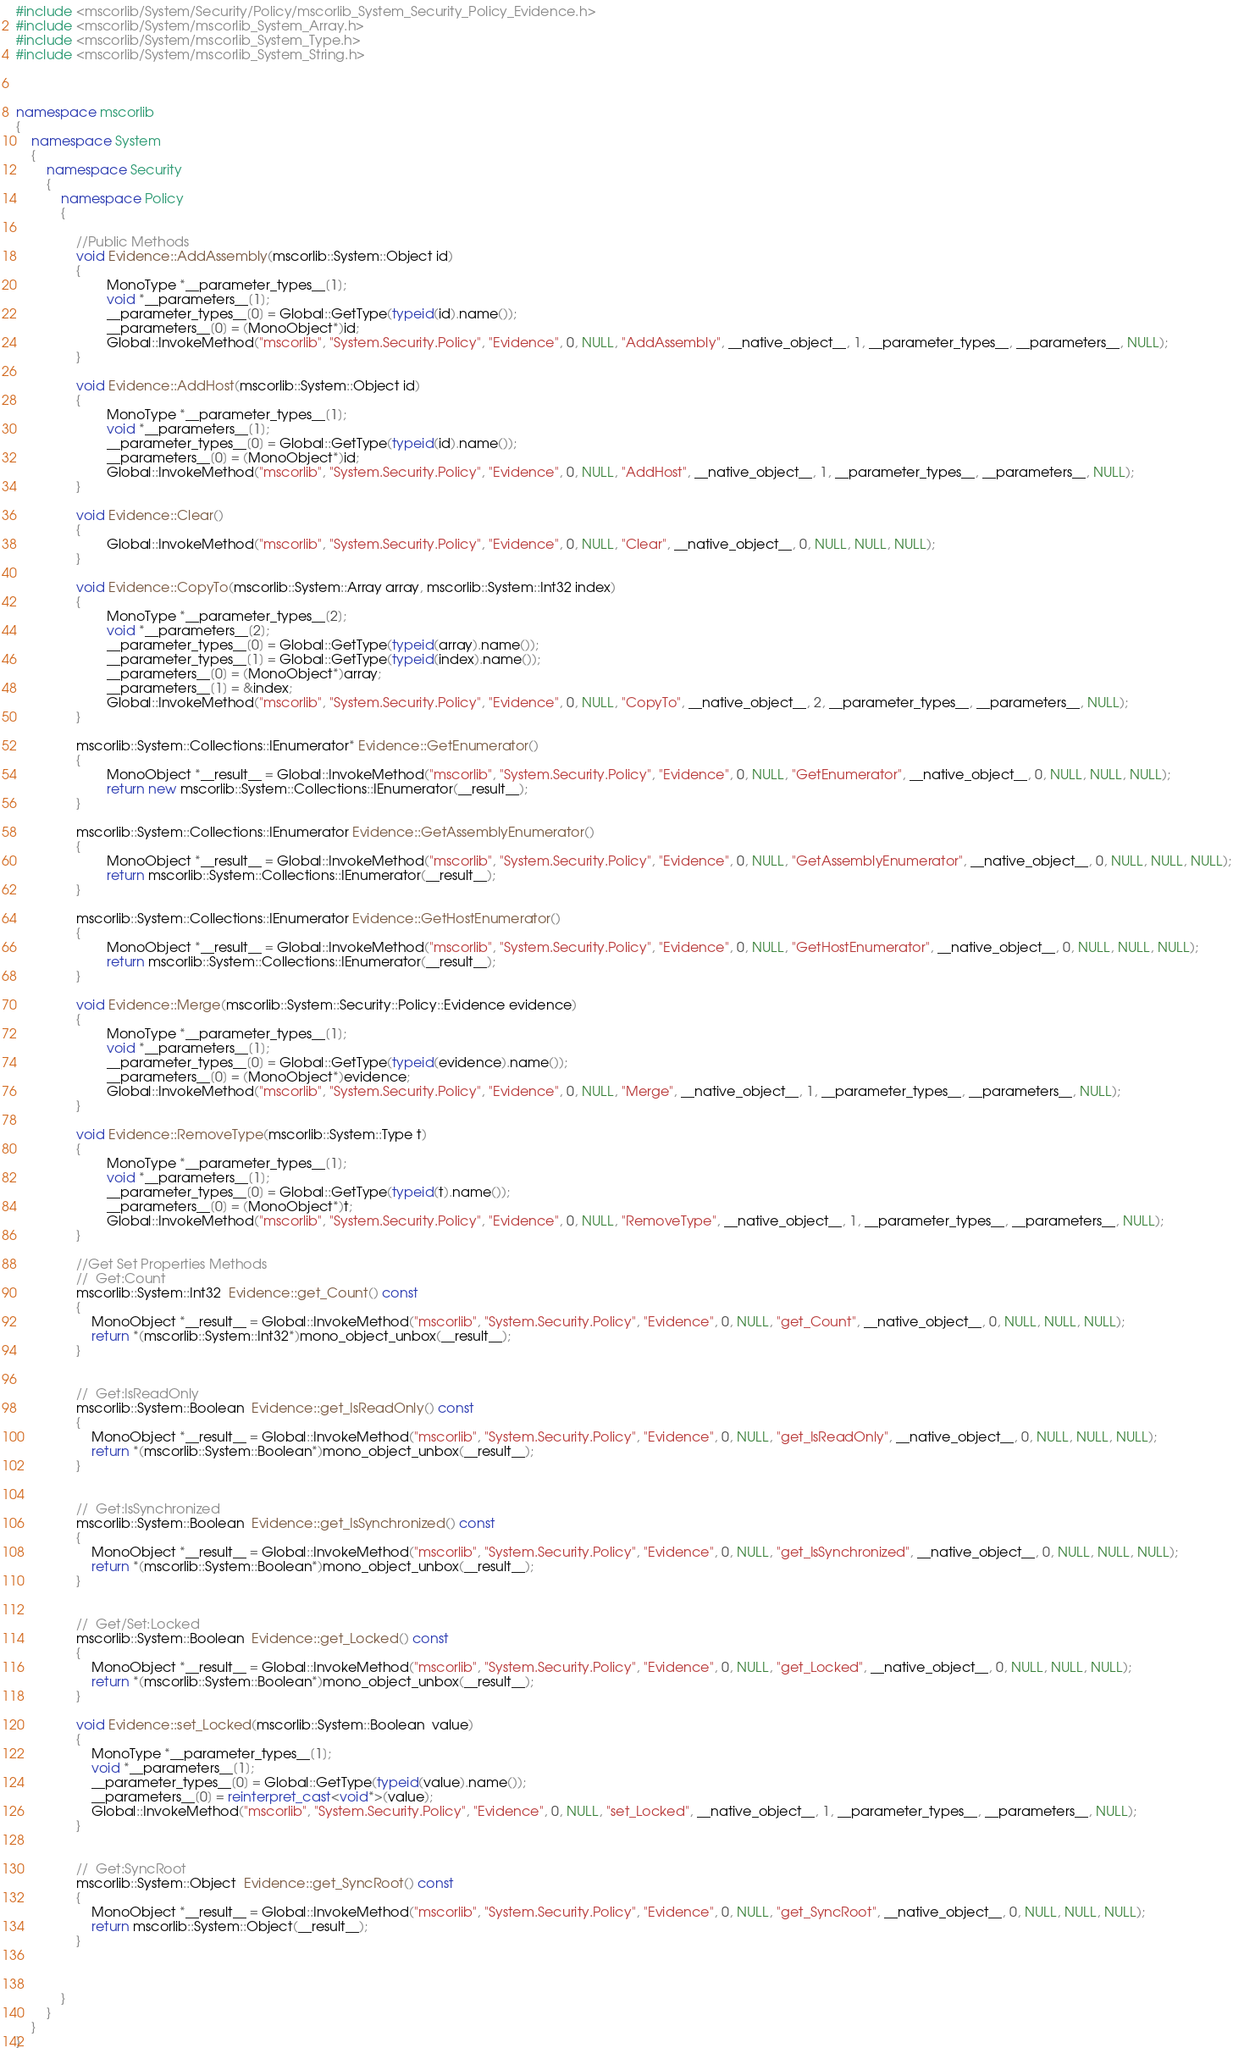<code> <loc_0><loc_0><loc_500><loc_500><_C++_>#include <mscorlib/System/Security/Policy/mscorlib_System_Security_Policy_Evidence.h>
#include <mscorlib/System/mscorlib_System_Array.h>
#include <mscorlib/System/mscorlib_System_Type.h>
#include <mscorlib/System/mscorlib_System_String.h>



namespace mscorlib
{
	namespace System
	{
		namespace Security
		{
			namespace Policy
			{

				//Public Methods
				void Evidence::AddAssembly(mscorlib::System::Object id)
				{
						MonoType *__parameter_types__[1];
						void *__parameters__[1];
						__parameter_types__[0] = Global::GetType(typeid(id).name());
						__parameters__[0] = (MonoObject*)id;
						Global::InvokeMethod("mscorlib", "System.Security.Policy", "Evidence", 0, NULL, "AddAssembly", __native_object__, 1, __parameter_types__, __parameters__, NULL);
				}

				void Evidence::AddHost(mscorlib::System::Object id)
				{
						MonoType *__parameter_types__[1];
						void *__parameters__[1];
						__parameter_types__[0] = Global::GetType(typeid(id).name());
						__parameters__[0] = (MonoObject*)id;
						Global::InvokeMethod("mscorlib", "System.Security.Policy", "Evidence", 0, NULL, "AddHost", __native_object__, 1, __parameter_types__, __parameters__, NULL);
				}

				void Evidence::Clear()
				{
						Global::InvokeMethod("mscorlib", "System.Security.Policy", "Evidence", 0, NULL, "Clear", __native_object__, 0, NULL, NULL, NULL);
				}

				void Evidence::CopyTo(mscorlib::System::Array array, mscorlib::System::Int32 index)
				{
						MonoType *__parameter_types__[2];
						void *__parameters__[2];
						__parameter_types__[0] = Global::GetType(typeid(array).name());
						__parameter_types__[1] = Global::GetType(typeid(index).name());
						__parameters__[0] = (MonoObject*)array;
						__parameters__[1] = &index;
						Global::InvokeMethod("mscorlib", "System.Security.Policy", "Evidence", 0, NULL, "CopyTo", __native_object__, 2, __parameter_types__, __parameters__, NULL);
				}

				mscorlib::System::Collections::IEnumerator* Evidence::GetEnumerator()
				{
						MonoObject *__result__ = Global::InvokeMethod("mscorlib", "System.Security.Policy", "Evidence", 0, NULL, "GetEnumerator", __native_object__, 0, NULL, NULL, NULL);
						return new mscorlib::System::Collections::IEnumerator(__result__);
				}

				mscorlib::System::Collections::IEnumerator Evidence::GetAssemblyEnumerator()
				{
						MonoObject *__result__ = Global::InvokeMethod("mscorlib", "System.Security.Policy", "Evidence", 0, NULL, "GetAssemblyEnumerator", __native_object__, 0, NULL, NULL, NULL);
						return mscorlib::System::Collections::IEnumerator(__result__);
				}

				mscorlib::System::Collections::IEnumerator Evidence::GetHostEnumerator()
				{
						MonoObject *__result__ = Global::InvokeMethod("mscorlib", "System.Security.Policy", "Evidence", 0, NULL, "GetHostEnumerator", __native_object__, 0, NULL, NULL, NULL);
						return mscorlib::System::Collections::IEnumerator(__result__);
				}

				void Evidence::Merge(mscorlib::System::Security::Policy::Evidence evidence)
				{
						MonoType *__parameter_types__[1];
						void *__parameters__[1];
						__parameter_types__[0] = Global::GetType(typeid(evidence).name());
						__parameters__[0] = (MonoObject*)evidence;
						Global::InvokeMethod("mscorlib", "System.Security.Policy", "Evidence", 0, NULL, "Merge", __native_object__, 1, __parameter_types__, __parameters__, NULL);
				}

				void Evidence::RemoveType(mscorlib::System::Type t)
				{
						MonoType *__parameter_types__[1];
						void *__parameters__[1];
						__parameter_types__[0] = Global::GetType(typeid(t).name());
						__parameters__[0] = (MonoObject*)t;
						Global::InvokeMethod("mscorlib", "System.Security.Policy", "Evidence", 0, NULL, "RemoveType", __native_object__, 1, __parameter_types__, __parameters__, NULL);
				}

				//Get Set Properties Methods
				//	Get:Count
				mscorlib::System::Int32  Evidence::get_Count() const
				{
					MonoObject *__result__ = Global::InvokeMethod("mscorlib", "System.Security.Policy", "Evidence", 0, NULL, "get_Count", __native_object__, 0, NULL, NULL, NULL);
					return *(mscorlib::System::Int32*)mono_object_unbox(__result__);
				}


				//	Get:IsReadOnly
				mscorlib::System::Boolean  Evidence::get_IsReadOnly() const
				{
					MonoObject *__result__ = Global::InvokeMethod("mscorlib", "System.Security.Policy", "Evidence", 0, NULL, "get_IsReadOnly", __native_object__, 0, NULL, NULL, NULL);
					return *(mscorlib::System::Boolean*)mono_object_unbox(__result__);
				}


				//	Get:IsSynchronized
				mscorlib::System::Boolean  Evidence::get_IsSynchronized() const
				{
					MonoObject *__result__ = Global::InvokeMethod("mscorlib", "System.Security.Policy", "Evidence", 0, NULL, "get_IsSynchronized", __native_object__, 0, NULL, NULL, NULL);
					return *(mscorlib::System::Boolean*)mono_object_unbox(__result__);
				}


				//	Get/Set:Locked
				mscorlib::System::Boolean  Evidence::get_Locked() const
				{
					MonoObject *__result__ = Global::InvokeMethod("mscorlib", "System.Security.Policy", "Evidence", 0, NULL, "get_Locked", __native_object__, 0, NULL, NULL, NULL);
					return *(mscorlib::System::Boolean*)mono_object_unbox(__result__);
				}

				void Evidence::set_Locked(mscorlib::System::Boolean  value)
				{
					MonoType *__parameter_types__[1];
					void *__parameters__[1];
					__parameter_types__[0] = Global::GetType(typeid(value).name());
					__parameters__[0] = reinterpret_cast<void*>(value);
					Global::InvokeMethod("mscorlib", "System.Security.Policy", "Evidence", 0, NULL, "set_Locked", __native_object__, 1, __parameter_types__, __parameters__, NULL);
				}


				//	Get:SyncRoot
				mscorlib::System::Object  Evidence::get_SyncRoot() const
				{
					MonoObject *__result__ = Global::InvokeMethod("mscorlib", "System.Security.Policy", "Evidence", 0, NULL, "get_SyncRoot", __native_object__, 0, NULL, NULL, NULL);
					return mscorlib::System::Object(__result__);
				}



			}
		}
	}
}
</code> 